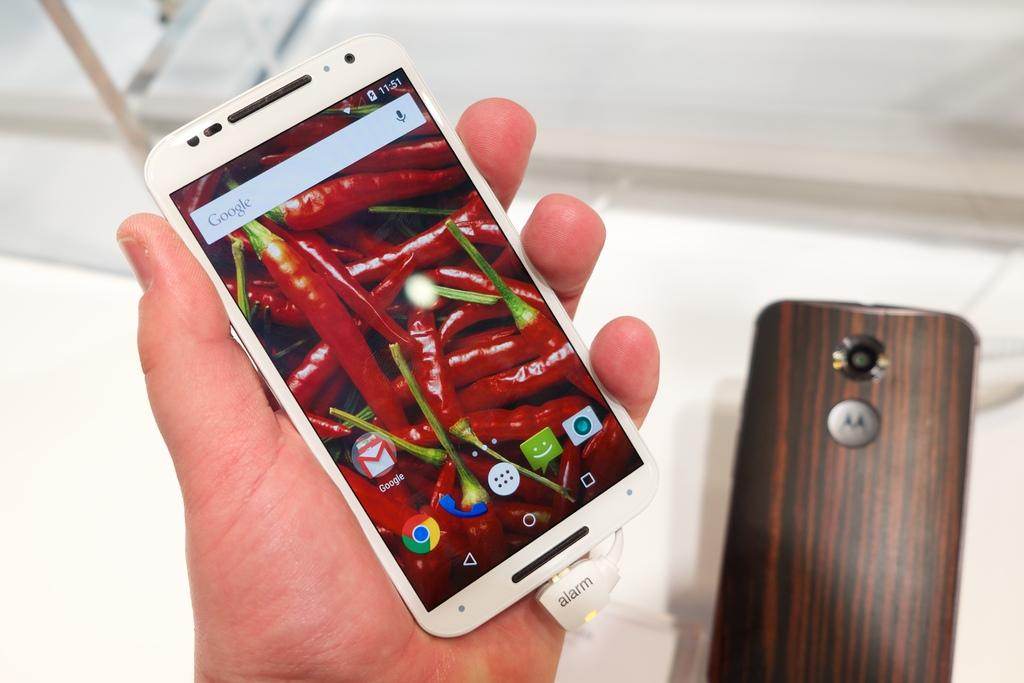Who or what is the main subject in the image? There is a person in the image. What is the person holding in their hand? The person is holding a mobile in their hand. Can you describe anything else visible in the image? There is another mobile visible in the background of the image. What type of coat is the person wearing in the image? There is no mention of a coat in the image, so it cannot be determined what type of coat the person might be wearing. 